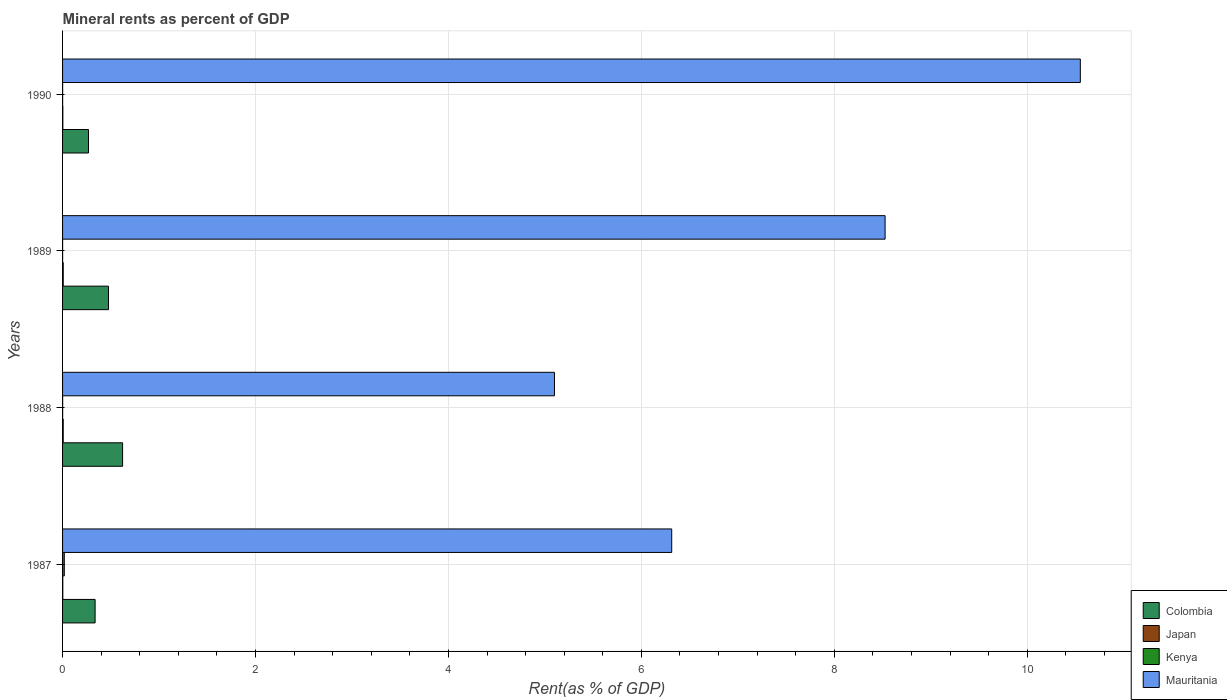How many bars are there on the 4th tick from the top?
Offer a terse response. 4. How many bars are there on the 2nd tick from the bottom?
Offer a very short reply. 4. What is the label of the 2nd group of bars from the top?
Make the answer very short. 1989. What is the mineral rent in Colombia in 1987?
Offer a terse response. 0.34. Across all years, what is the maximum mineral rent in Japan?
Keep it short and to the point. 0.01. Across all years, what is the minimum mineral rent in Kenya?
Your answer should be very brief. 0. In which year was the mineral rent in Japan maximum?
Offer a very short reply. 1989. What is the total mineral rent in Mauritania in the graph?
Ensure brevity in your answer.  30.49. What is the difference between the mineral rent in Kenya in 1988 and that in 1990?
Offer a very short reply. 0. What is the difference between the mineral rent in Mauritania in 1990 and the mineral rent in Colombia in 1988?
Offer a terse response. 9.93. What is the average mineral rent in Japan per year?
Offer a very short reply. 0. In the year 1988, what is the difference between the mineral rent in Mauritania and mineral rent in Japan?
Offer a terse response. 5.09. What is the ratio of the mineral rent in Mauritania in 1987 to that in 1988?
Ensure brevity in your answer.  1.24. What is the difference between the highest and the second highest mineral rent in Colombia?
Ensure brevity in your answer.  0.15. What is the difference between the highest and the lowest mineral rent in Colombia?
Your answer should be compact. 0.35. Is it the case that in every year, the sum of the mineral rent in Mauritania and mineral rent in Colombia is greater than the sum of mineral rent in Kenya and mineral rent in Japan?
Give a very brief answer. Yes. What does the 2nd bar from the top in 1988 represents?
Keep it short and to the point. Kenya. What does the 4th bar from the bottom in 1989 represents?
Your response must be concise. Mauritania. Are all the bars in the graph horizontal?
Provide a short and direct response. Yes. How many years are there in the graph?
Provide a succinct answer. 4. Are the values on the major ticks of X-axis written in scientific E-notation?
Offer a terse response. No. Does the graph contain any zero values?
Provide a short and direct response. No. Does the graph contain grids?
Offer a very short reply. Yes. How are the legend labels stacked?
Offer a very short reply. Vertical. What is the title of the graph?
Provide a succinct answer. Mineral rents as percent of GDP. What is the label or title of the X-axis?
Provide a short and direct response. Rent(as % of GDP). What is the Rent(as % of GDP) of Colombia in 1987?
Offer a very short reply. 0.34. What is the Rent(as % of GDP) in Japan in 1987?
Your response must be concise. 0. What is the Rent(as % of GDP) of Kenya in 1987?
Keep it short and to the point. 0.02. What is the Rent(as % of GDP) of Mauritania in 1987?
Make the answer very short. 6.31. What is the Rent(as % of GDP) in Colombia in 1988?
Offer a very short reply. 0.62. What is the Rent(as % of GDP) in Japan in 1988?
Ensure brevity in your answer.  0.01. What is the Rent(as % of GDP) in Kenya in 1988?
Provide a short and direct response. 0. What is the Rent(as % of GDP) in Mauritania in 1988?
Your answer should be compact. 5.1. What is the Rent(as % of GDP) of Colombia in 1989?
Your answer should be very brief. 0.48. What is the Rent(as % of GDP) in Japan in 1989?
Make the answer very short. 0.01. What is the Rent(as % of GDP) of Kenya in 1989?
Give a very brief answer. 0. What is the Rent(as % of GDP) in Mauritania in 1989?
Offer a terse response. 8.53. What is the Rent(as % of GDP) in Colombia in 1990?
Give a very brief answer. 0.27. What is the Rent(as % of GDP) of Japan in 1990?
Ensure brevity in your answer.  0. What is the Rent(as % of GDP) in Kenya in 1990?
Make the answer very short. 0. What is the Rent(as % of GDP) of Mauritania in 1990?
Provide a short and direct response. 10.55. Across all years, what is the maximum Rent(as % of GDP) in Colombia?
Offer a terse response. 0.62. Across all years, what is the maximum Rent(as % of GDP) in Japan?
Provide a short and direct response. 0.01. Across all years, what is the maximum Rent(as % of GDP) in Kenya?
Offer a terse response. 0.02. Across all years, what is the maximum Rent(as % of GDP) in Mauritania?
Keep it short and to the point. 10.55. Across all years, what is the minimum Rent(as % of GDP) in Colombia?
Your answer should be very brief. 0.27. Across all years, what is the minimum Rent(as % of GDP) of Japan?
Your answer should be very brief. 0. Across all years, what is the minimum Rent(as % of GDP) of Kenya?
Provide a succinct answer. 0. Across all years, what is the minimum Rent(as % of GDP) of Mauritania?
Provide a succinct answer. 5.1. What is the total Rent(as % of GDP) of Colombia in the graph?
Offer a terse response. 1.7. What is the total Rent(as % of GDP) in Japan in the graph?
Keep it short and to the point. 0.02. What is the total Rent(as % of GDP) of Kenya in the graph?
Provide a succinct answer. 0.02. What is the total Rent(as % of GDP) of Mauritania in the graph?
Give a very brief answer. 30.49. What is the difference between the Rent(as % of GDP) of Colombia in 1987 and that in 1988?
Your response must be concise. -0.28. What is the difference between the Rent(as % of GDP) of Japan in 1987 and that in 1988?
Your answer should be very brief. -0. What is the difference between the Rent(as % of GDP) in Kenya in 1987 and that in 1988?
Ensure brevity in your answer.  0.02. What is the difference between the Rent(as % of GDP) in Mauritania in 1987 and that in 1988?
Give a very brief answer. 1.22. What is the difference between the Rent(as % of GDP) in Colombia in 1987 and that in 1989?
Ensure brevity in your answer.  -0.14. What is the difference between the Rent(as % of GDP) of Japan in 1987 and that in 1989?
Offer a terse response. -0. What is the difference between the Rent(as % of GDP) of Kenya in 1987 and that in 1989?
Give a very brief answer. 0.02. What is the difference between the Rent(as % of GDP) of Mauritania in 1987 and that in 1989?
Ensure brevity in your answer.  -2.21. What is the difference between the Rent(as % of GDP) in Colombia in 1987 and that in 1990?
Ensure brevity in your answer.  0.07. What is the difference between the Rent(as % of GDP) of Japan in 1987 and that in 1990?
Ensure brevity in your answer.  -0. What is the difference between the Rent(as % of GDP) in Kenya in 1987 and that in 1990?
Offer a terse response. 0.02. What is the difference between the Rent(as % of GDP) of Mauritania in 1987 and that in 1990?
Make the answer very short. -4.24. What is the difference between the Rent(as % of GDP) of Colombia in 1988 and that in 1989?
Your answer should be compact. 0.15. What is the difference between the Rent(as % of GDP) of Japan in 1988 and that in 1989?
Offer a very short reply. -0. What is the difference between the Rent(as % of GDP) in Mauritania in 1988 and that in 1989?
Offer a terse response. -3.43. What is the difference between the Rent(as % of GDP) in Colombia in 1988 and that in 1990?
Give a very brief answer. 0.35. What is the difference between the Rent(as % of GDP) in Japan in 1988 and that in 1990?
Offer a terse response. 0. What is the difference between the Rent(as % of GDP) in Mauritania in 1988 and that in 1990?
Ensure brevity in your answer.  -5.45. What is the difference between the Rent(as % of GDP) in Colombia in 1989 and that in 1990?
Your answer should be compact. 0.21. What is the difference between the Rent(as % of GDP) of Japan in 1989 and that in 1990?
Offer a very short reply. 0. What is the difference between the Rent(as % of GDP) of Kenya in 1989 and that in 1990?
Your answer should be very brief. -0. What is the difference between the Rent(as % of GDP) of Mauritania in 1989 and that in 1990?
Offer a very short reply. -2.02. What is the difference between the Rent(as % of GDP) of Colombia in 1987 and the Rent(as % of GDP) of Japan in 1988?
Ensure brevity in your answer.  0.33. What is the difference between the Rent(as % of GDP) of Colombia in 1987 and the Rent(as % of GDP) of Kenya in 1988?
Provide a short and direct response. 0.34. What is the difference between the Rent(as % of GDP) of Colombia in 1987 and the Rent(as % of GDP) of Mauritania in 1988?
Keep it short and to the point. -4.76. What is the difference between the Rent(as % of GDP) in Japan in 1987 and the Rent(as % of GDP) in Kenya in 1988?
Keep it short and to the point. 0. What is the difference between the Rent(as % of GDP) in Japan in 1987 and the Rent(as % of GDP) in Mauritania in 1988?
Provide a succinct answer. -5.1. What is the difference between the Rent(as % of GDP) in Kenya in 1987 and the Rent(as % of GDP) in Mauritania in 1988?
Offer a terse response. -5.08. What is the difference between the Rent(as % of GDP) of Colombia in 1987 and the Rent(as % of GDP) of Japan in 1989?
Offer a terse response. 0.33. What is the difference between the Rent(as % of GDP) of Colombia in 1987 and the Rent(as % of GDP) of Kenya in 1989?
Give a very brief answer. 0.34. What is the difference between the Rent(as % of GDP) in Colombia in 1987 and the Rent(as % of GDP) in Mauritania in 1989?
Offer a very short reply. -8.19. What is the difference between the Rent(as % of GDP) of Japan in 1987 and the Rent(as % of GDP) of Kenya in 1989?
Offer a terse response. 0. What is the difference between the Rent(as % of GDP) of Japan in 1987 and the Rent(as % of GDP) of Mauritania in 1989?
Your answer should be compact. -8.52. What is the difference between the Rent(as % of GDP) of Kenya in 1987 and the Rent(as % of GDP) of Mauritania in 1989?
Your answer should be compact. -8.51. What is the difference between the Rent(as % of GDP) in Colombia in 1987 and the Rent(as % of GDP) in Japan in 1990?
Provide a succinct answer. 0.33. What is the difference between the Rent(as % of GDP) of Colombia in 1987 and the Rent(as % of GDP) of Kenya in 1990?
Your answer should be compact. 0.34. What is the difference between the Rent(as % of GDP) of Colombia in 1987 and the Rent(as % of GDP) of Mauritania in 1990?
Offer a terse response. -10.21. What is the difference between the Rent(as % of GDP) in Japan in 1987 and the Rent(as % of GDP) in Kenya in 1990?
Provide a succinct answer. 0. What is the difference between the Rent(as % of GDP) in Japan in 1987 and the Rent(as % of GDP) in Mauritania in 1990?
Offer a very short reply. -10.55. What is the difference between the Rent(as % of GDP) in Kenya in 1987 and the Rent(as % of GDP) in Mauritania in 1990?
Your response must be concise. -10.53. What is the difference between the Rent(as % of GDP) in Colombia in 1988 and the Rent(as % of GDP) in Japan in 1989?
Keep it short and to the point. 0.62. What is the difference between the Rent(as % of GDP) of Colombia in 1988 and the Rent(as % of GDP) of Kenya in 1989?
Your answer should be very brief. 0.62. What is the difference between the Rent(as % of GDP) of Colombia in 1988 and the Rent(as % of GDP) of Mauritania in 1989?
Your response must be concise. -7.9. What is the difference between the Rent(as % of GDP) of Japan in 1988 and the Rent(as % of GDP) of Kenya in 1989?
Keep it short and to the point. 0.01. What is the difference between the Rent(as % of GDP) of Japan in 1988 and the Rent(as % of GDP) of Mauritania in 1989?
Provide a succinct answer. -8.52. What is the difference between the Rent(as % of GDP) of Kenya in 1988 and the Rent(as % of GDP) of Mauritania in 1989?
Your answer should be compact. -8.53. What is the difference between the Rent(as % of GDP) in Colombia in 1988 and the Rent(as % of GDP) in Japan in 1990?
Provide a succinct answer. 0.62. What is the difference between the Rent(as % of GDP) of Colombia in 1988 and the Rent(as % of GDP) of Kenya in 1990?
Give a very brief answer. 0.62. What is the difference between the Rent(as % of GDP) in Colombia in 1988 and the Rent(as % of GDP) in Mauritania in 1990?
Your answer should be compact. -9.93. What is the difference between the Rent(as % of GDP) in Japan in 1988 and the Rent(as % of GDP) in Kenya in 1990?
Make the answer very short. 0.01. What is the difference between the Rent(as % of GDP) of Japan in 1988 and the Rent(as % of GDP) of Mauritania in 1990?
Provide a short and direct response. -10.54. What is the difference between the Rent(as % of GDP) in Kenya in 1988 and the Rent(as % of GDP) in Mauritania in 1990?
Your response must be concise. -10.55. What is the difference between the Rent(as % of GDP) of Colombia in 1989 and the Rent(as % of GDP) of Japan in 1990?
Give a very brief answer. 0.47. What is the difference between the Rent(as % of GDP) in Colombia in 1989 and the Rent(as % of GDP) in Kenya in 1990?
Offer a very short reply. 0.48. What is the difference between the Rent(as % of GDP) of Colombia in 1989 and the Rent(as % of GDP) of Mauritania in 1990?
Your answer should be very brief. -10.07. What is the difference between the Rent(as % of GDP) of Japan in 1989 and the Rent(as % of GDP) of Kenya in 1990?
Ensure brevity in your answer.  0.01. What is the difference between the Rent(as % of GDP) in Japan in 1989 and the Rent(as % of GDP) in Mauritania in 1990?
Provide a short and direct response. -10.54. What is the difference between the Rent(as % of GDP) of Kenya in 1989 and the Rent(as % of GDP) of Mauritania in 1990?
Offer a terse response. -10.55. What is the average Rent(as % of GDP) in Colombia per year?
Provide a short and direct response. 0.43. What is the average Rent(as % of GDP) of Japan per year?
Make the answer very short. 0. What is the average Rent(as % of GDP) of Kenya per year?
Give a very brief answer. 0.01. What is the average Rent(as % of GDP) in Mauritania per year?
Your answer should be very brief. 7.62. In the year 1987, what is the difference between the Rent(as % of GDP) in Colombia and Rent(as % of GDP) in Japan?
Your response must be concise. 0.33. In the year 1987, what is the difference between the Rent(as % of GDP) in Colombia and Rent(as % of GDP) in Kenya?
Offer a very short reply. 0.32. In the year 1987, what is the difference between the Rent(as % of GDP) in Colombia and Rent(as % of GDP) in Mauritania?
Provide a succinct answer. -5.98. In the year 1987, what is the difference between the Rent(as % of GDP) in Japan and Rent(as % of GDP) in Kenya?
Make the answer very short. -0.02. In the year 1987, what is the difference between the Rent(as % of GDP) in Japan and Rent(as % of GDP) in Mauritania?
Give a very brief answer. -6.31. In the year 1987, what is the difference between the Rent(as % of GDP) in Kenya and Rent(as % of GDP) in Mauritania?
Offer a terse response. -6.3. In the year 1988, what is the difference between the Rent(as % of GDP) in Colombia and Rent(as % of GDP) in Japan?
Ensure brevity in your answer.  0.62. In the year 1988, what is the difference between the Rent(as % of GDP) in Colombia and Rent(as % of GDP) in Kenya?
Your answer should be compact. 0.62. In the year 1988, what is the difference between the Rent(as % of GDP) of Colombia and Rent(as % of GDP) of Mauritania?
Provide a succinct answer. -4.48. In the year 1988, what is the difference between the Rent(as % of GDP) in Japan and Rent(as % of GDP) in Kenya?
Offer a very short reply. 0.01. In the year 1988, what is the difference between the Rent(as % of GDP) of Japan and Rent(as % of GDP) of Mauritania?
Ensure brevity in your answer.  -5.09. In the year 1988, what is the difference between the Rent(as % of GDP) of Kenya and Rent(as % of GDP) of Mauritania?
Offer a very short reply. -5.1. In the year 1989, what is the difference between the Rent(as % of GDP) in Colombia and Rent(as % of GDP) in Japan?
Provide a short and direct response. 0.47. In the year 1989, what is the difference between the Rent(as % of GDP) in Colombia and Rent(as % of GDP) in Kenya?
Provide a succinct answer. 0.48. In the year 1989, what is the difference between the Rent(as % of GDP) in Colombia and Rent(as % of GDP) in Mauritania?
Offer a very short reply. -8.05. In the year 1989, what is the difference between the Rent(as % of GDP) in Japan and Rent(as % of GDP) in Kenya?
Provide a succinct answer. 0.01. In the year 1989, what is the difference between the Rent(as % of GDP) of Japan and Rent(as % of GDP) of Mauritania?
Provide a succinct answer. -8.52. In the year 1989, what is the difference between the Rent(as % of GDP) in Kenya and Rent(as % of GDP) in Mauritania?
Give a very brief answer. -8.53. In the year 1990, what is the difference between the Rent(as % of GDP) of Colombia and Rent(as % of GDP) of Japan?
Keep it short and to the point. 0.27. In the year 1990, what is the difference between the Rent(as % of GDP) in Colombia and Rent(as % of GDP) in Kenya?
Your answer should be compact. 0.27. In the year 1990, what is the difference between the Rent(as % of GDP) of Colombia and Rent(as % of GDP) of Mauritania?
Your answer should be very brief. -10.28. In the year 1990, what is the difference between the Rent(as % of GDP) of Japan and Rent(as % of GDP) of Kenya?
Your answer should be very brief. 0. In the year 1990, what is the difference between the Rent(as % of GDP) of Japan and Rent(as % of GDP) of Mauritania?
Offer a very short reply. -10.55. In the year 1990, what is the difference between the Rent(as % of GDP) of Kenya and Rent(as % of GDP) of Mauritania?
Your answer should be compact. -10.55. What is the ratio of the Rent(as % of GDP) of Colombia in 1987 to that in 1988?
Offer a terse response. 0.54. What is the ratio of the Rent(as % of GDP) of Japan in 1987 to that in 1988?
Offer a very short reply. 0.36. What is the ratio of the Rent(as % of GDP) of Kenya in 1987 to that in 1988?
Make the answer very short. 20.79. What is the ratio of the Rent(as % of GDP) of Mauritania in 1987 to that in 1988?
Make the answer very short. 1.24. What is the ratio of the Rent(as % of GDP) of Colombia in 1987 to that in 1989?
Ensure brevity in your answer.  0.71. What is the ratio of the Rent(as % of GDP) in Japan in 1987 to that in 1989?
Your answer should be compact. 0.35. What is the ratio of the Rent(as % of GDP) of Kenya in 1987 to that in 1989?
Give a very brief answer. 39.44. What is the ratio of the Rent(as % of GDP) in Mauritania in 1987 to that in 1989?
Offer a terse response. 0.74. What is the ratio of the Rent(as % of GDP) of Colombia in 1987 to that in 1990?
Provide a short and direct response. 1.25. What is the ratio of the Rent(as % of GDP) of Japan in 1987 to that in 1990?
Make the answer very short. 0.82. What is the ratio of the Rent(as % of GDP) of Kenya in 1987 to that in 1990?
Offer a terse response. 27.9. What is the ratio of the Rent(as % of GDP) in Mauritania in 1987 to that in 1990?
Give a very brief answer. 0.6. What is the ratio of the Rent(as % of GDP) in Colombia in 1988 to that in 1989?
Offer a very short reply. 1.31. What is the ratio of the Rent(as % of GDP) in Japan in 1988 to that in 1989?
Ensure brevity in your answer.  0.98. What is the ratio of the Rent(as % of GDP) in Kenya in 1988 to that in 1989?
Your response must be concise. 1.9. What is the ratio of the Rent(as % of GDP) of Mauritania in 1988 to that in 1989?
Offer a terse response. 0.6. What is the ratio of the Rent(as % of GDP) of Colombia in 1988 to that in 1990?
Ensure brevity in your answer.  2.31. What is the ratio of the Rent(as % of GDP) of Japan in 1988 to that in 1990?
Your answer should be very brief. 2.3. What is the ratio of the Rent(as % of GDP) of Kenya in 1988 to that in 1990?
Your response must be concise. 1.34. What is the ratio of the Rent(as % of GDP) in Mauritania in 1988 to that in 1990?
Make the answer very short. 0.48. What is the ratio of the Rent(as % of GDP) in Colombia in 1989 to that in 1990?
Ensure brevity in your answer.  1.77. What is the ratio of the Rent(as % of GDP) of Japan in 1989 to that in 1990?
Give a very brief answer. 2.36. What is the ratio of the Rent(as % of GDP) in Kenya in 1989 to that in 1990?
Give a very brief answer. 0.71. What is the ratio of the Rent(as % of GDP) in Mauritania in 1989 to that in 1990?
Provide a short and direct response. 0.81. What is the difference between the highest and the second highest Rent(as % of GDP) of Colombia?
Your response must be concise. 0.15. What is the difference between the highest and the second highest Rent(as % of GDP) of Kenya?
Your response must be concise. 0.02. What is the difference between the highest and the second highest Rent(as % of GDP) of Mauritania?
Keep it short and to the point. 2.02. What is the difference between the highest and the lowest Rent(as % of GDP) in Colombia?
Provide a short and direct response. 0.35. What is the difference between the highest and the lowest Rent(as % of GDP) in Japan?
Ensure brevity in your answer.  0. What is the difference between the highest and the lowest Rent(as % of GDP) in Kenya?
Your answer should be very brief. 0.02. What is the difference between the highest and the lowest Rent(as % of GDP) of Mauritania?
Your answer should be very brief. 5.45. 